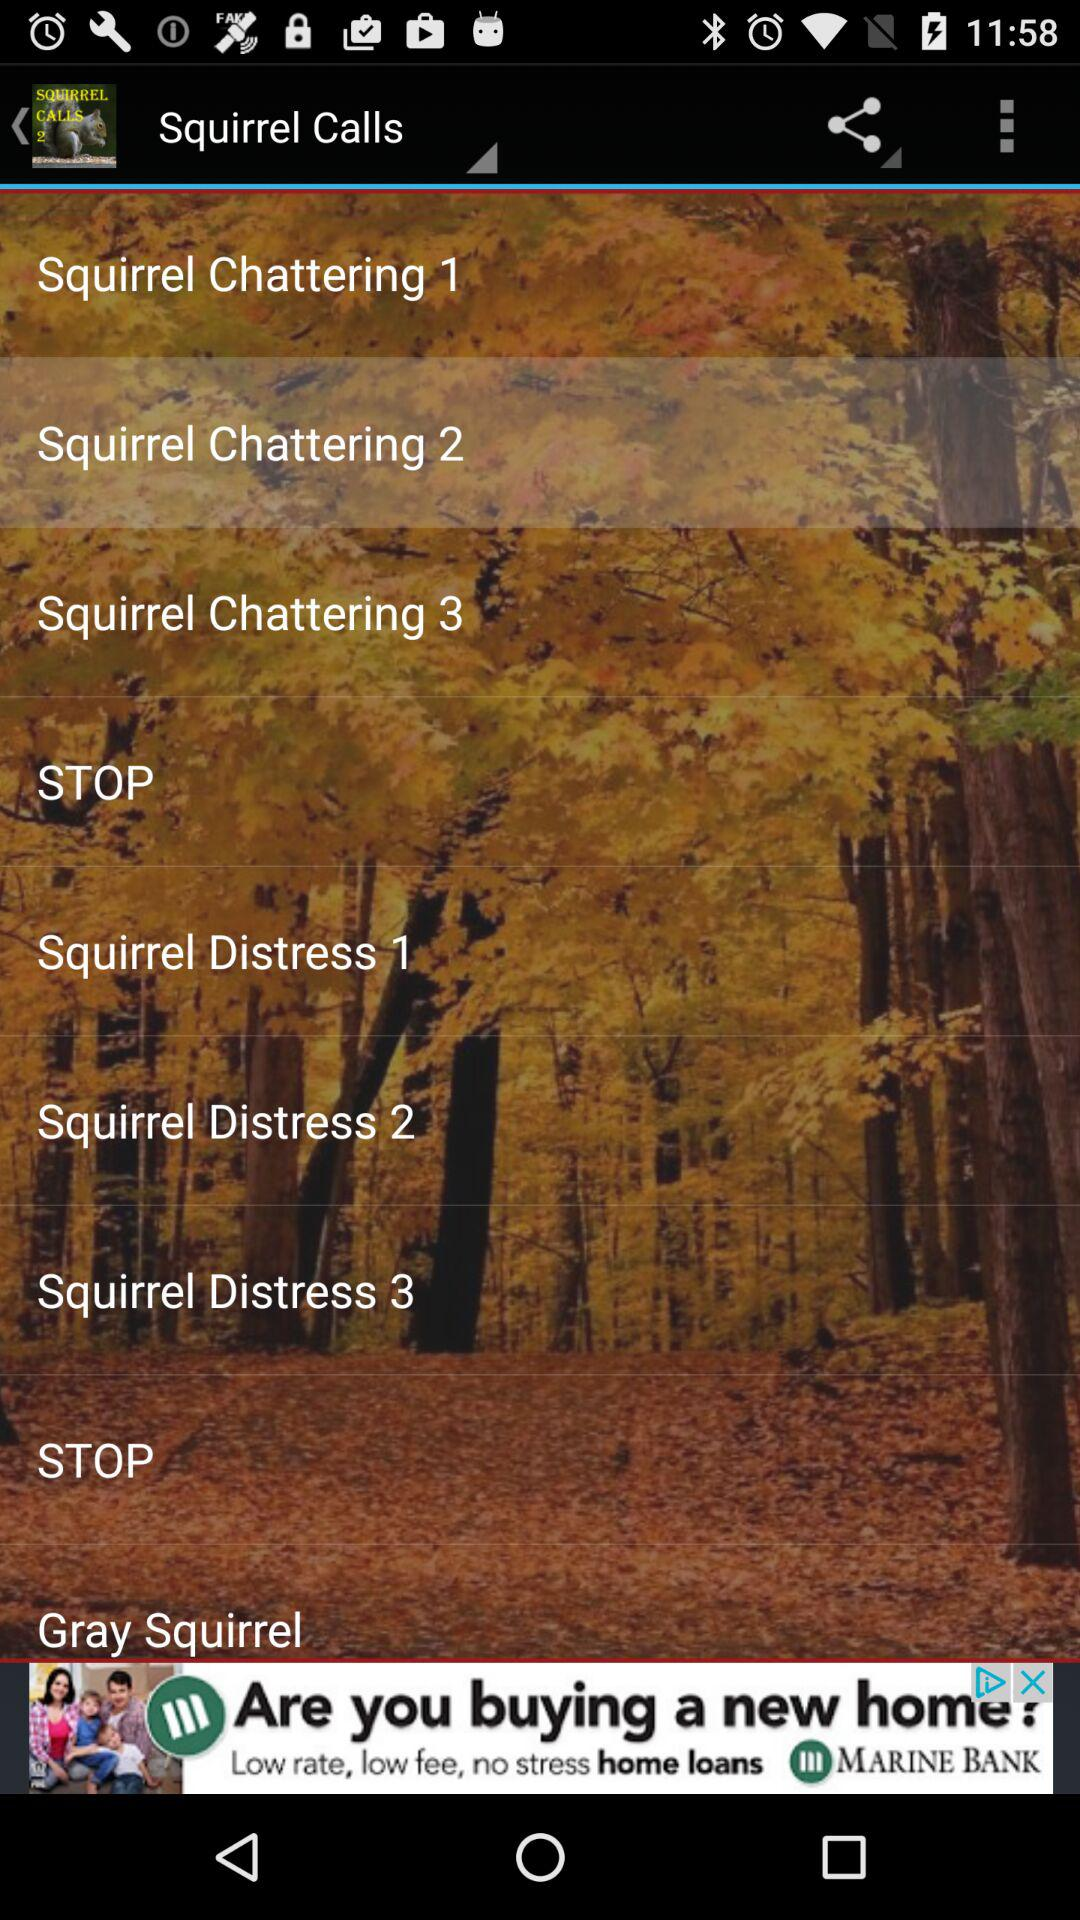What is the name of the application? The name of the application is "Squirrel Calls 2". 